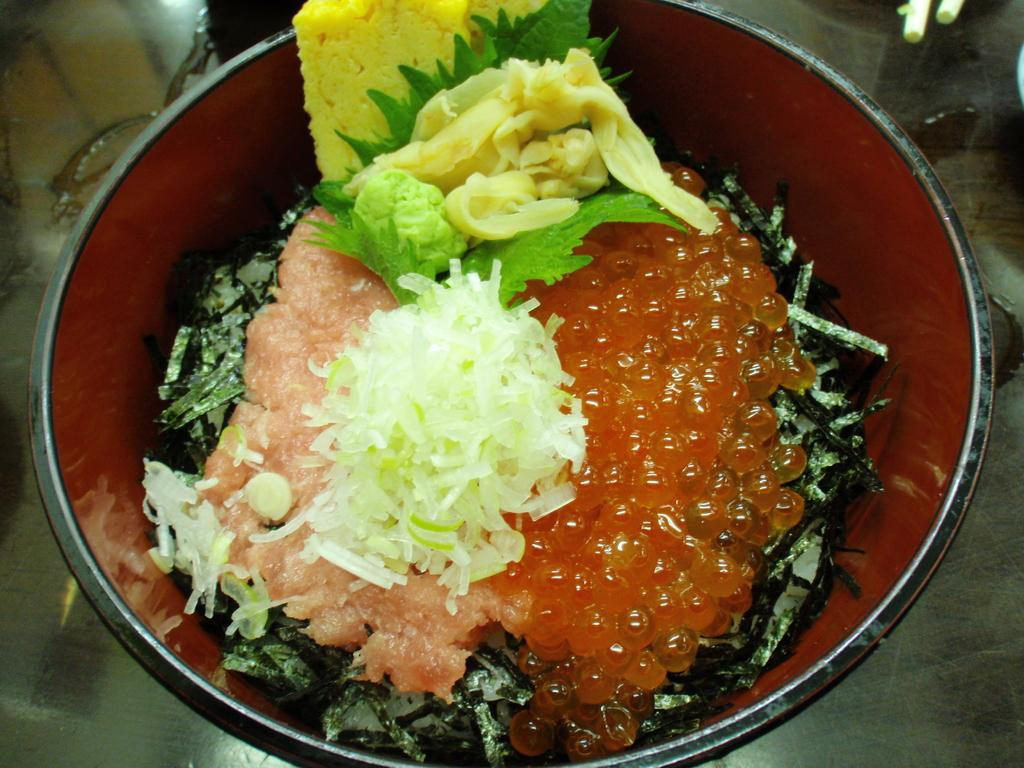What is in the bowl that is visible in the image? There is a bowl of food in the image. Where is the bowl of food located? The bowl of food is placed on a table. What type of sweater is being sorted by the bird in the image? There is no sweater or bird present in the image; it only features a bowl of food placed on a table. 